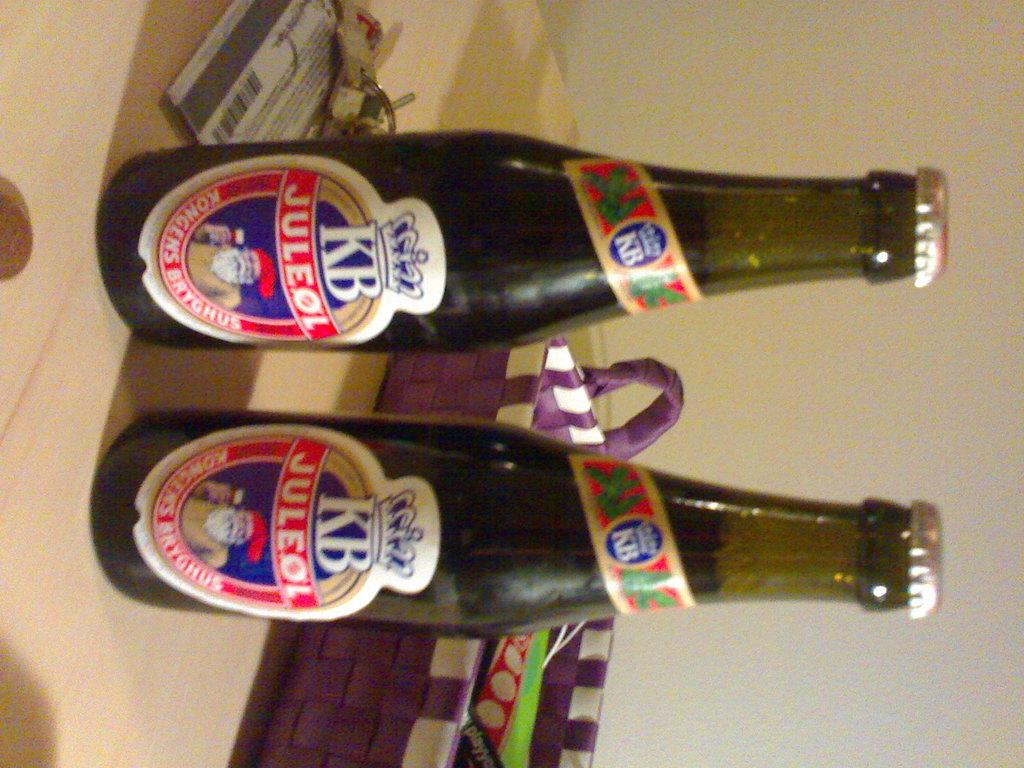<image>
Relay a brief, clear account of the picture shown. Two beer bottles of KB Juleol sitting on a table by some keys 